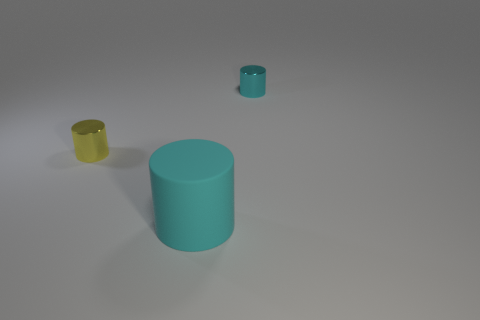Add 3 small things. How many objects exist? 6 Subtract all big cylinders. How many cylinders are left? 2 Subtract all yellow cylinders. How many cylinders are left? 2 Subtract 1 cylinders. How many cylinders are left? 2 Add 2 large red shiny blocks. How many large red shiny blocks exist? 2 Subtract 0 purple blocks. How many objects are left? 3 Subtract all green cylinders. Subtract all blue spheres. How many cylinders are left? 3 Subtract all red cubes. How many purple cylinders are left? 0 Subtract all large objects. Subtract all large cyan matte cylinders. How many objects are left? 1 Add 2 cyan metallic cylinders. How many cyan metallic cylinders are left? 3 